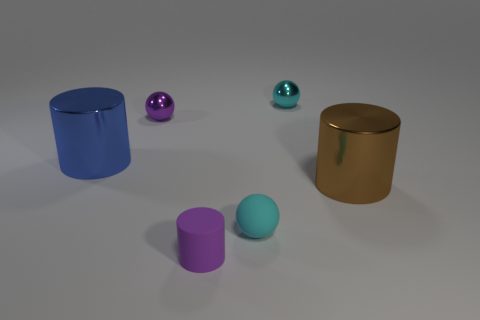There is a shiny object that is behind the big blue metal cylinder and on the right side of the small cyan rubber sphere; what color is it?
Your response must be concise. Cyan. There is a metallic ball on the right side of the cyan matte object; does it have the same size as the metallic cylinder on the left side of the cyan matte thing?
Provide a succinct answer. No. What number of things are either metallic objects that are right of the large blue metal cylinder or tiny rubber cylinders?
Provide a short and direct response. 4. What material is the big blue object?
Provide a succinct answer. Metal. Do the brown cylinder and the cyan matte ball have the same size?
Your answer should be very brief. No. How many blocks are gray things or tiny purple things?
Your response must be concise. 0. There is a large cylinder on the right side of the large cylinder that is left of the rubber cylinder; what is its color?
Offer a terse response. Brown. Are there fewer small purple cylinders that are to the right of the small cyan metallic thing than tiny purple things that are behind the big brown shiny cylinder?
Offer a terse response. Yes. Do the purple matte thing and the metallic ball on the left side of the small cylinder have the same size?
Keep it short and to the point. Yes. There is a thing that is both right of the matte cylinder and in front of the big brown thing; what shape is it?
Your answer should be very brief. Sphere. 